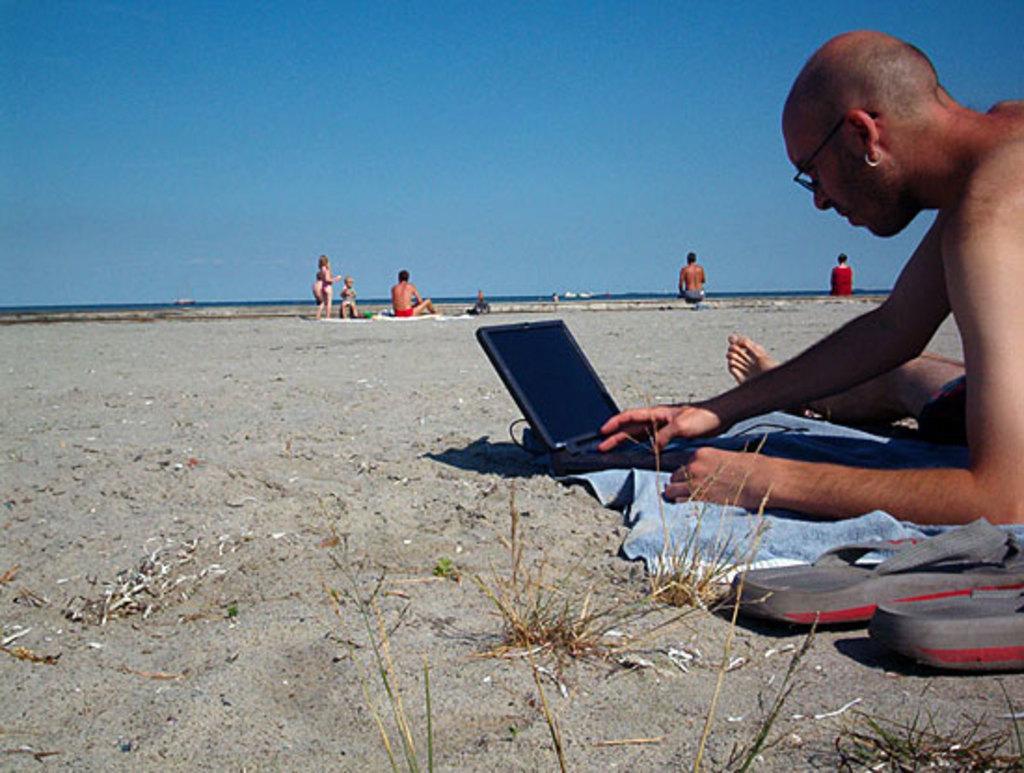Please provide a concise description of this image. This is an outside view. On the right side there is a man sitting on a cloth which is placed on the ground and looking into the laptop. Beside him, I can see the footwear. This place is looking like a beach. In the background, I can see few people sitting and also there are some children. At the top of the image I can see the sky in blue color. 